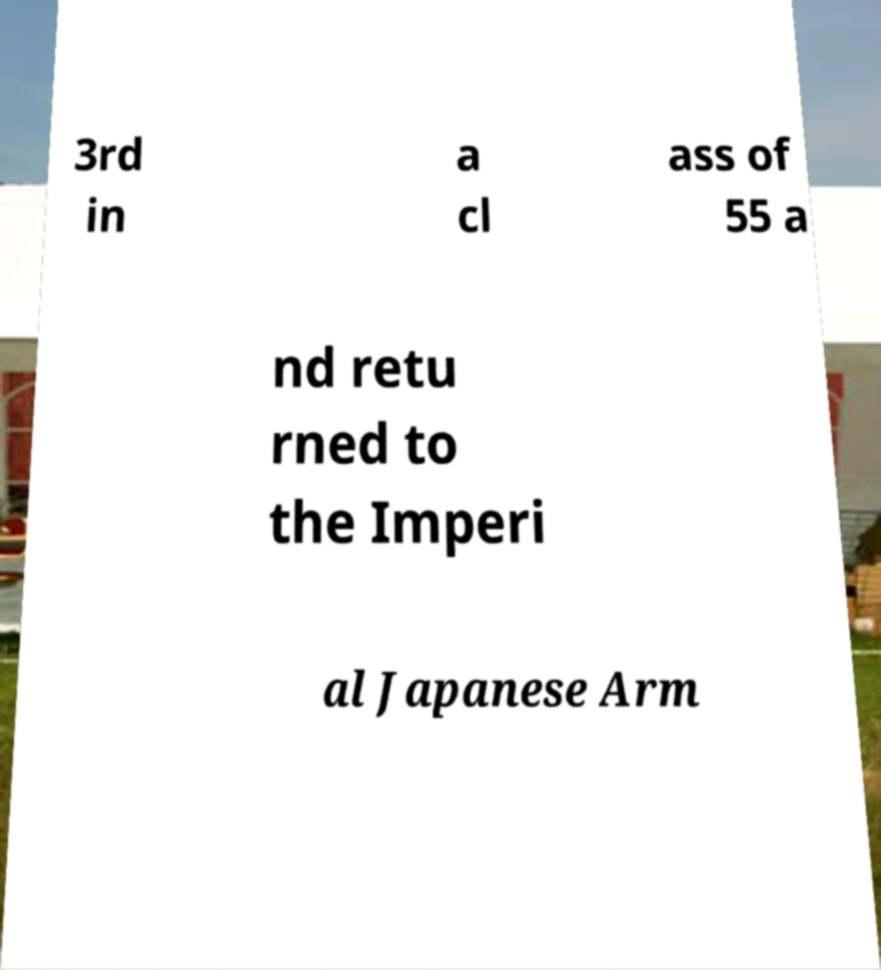Could you assist in decoding the text presented in this image and type it out clearly? 3rd in a cl ass of 55 a nd retu rned to the Imperi al Japanese Arm 